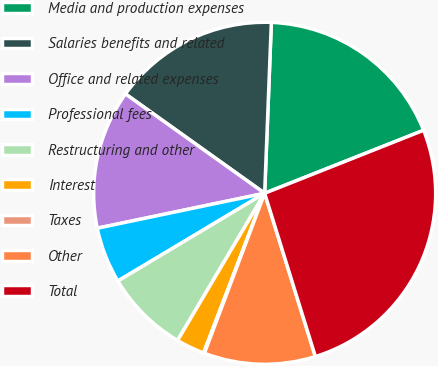<chart> <loc_0><loc_0><loc_500><loc_500><pie_chart><fcel>Media and production expenses<fcel>Salaries benefits and related<fcel>Office and related expenses<fcel>Professional fees<fcel>Restructuring and other<fcel>Interest<fcel>Taxes<fcel>Other<fcel>Total<nl><fcel>18.37%<fcel>15.76%<fcel>13.14%<fcel>5.3%<fcel>7.92%<fcel>2.69%<fcel>0.08%<fcel>10.53%<fcel>26.21%<nl></chart> 